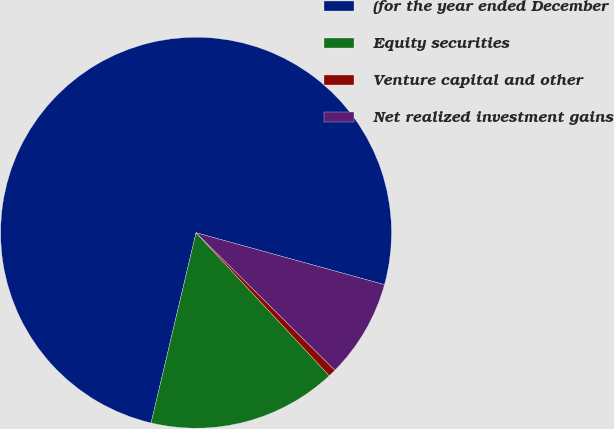Convert chart. <chart><loc_0><loc_0><loc_500><loc_500><pie_chart><fcel>(for the year ended December<fcel>Equity securities<fcel>Venture capital and other<fcel>Net realized investment gains<nl><fcel>75.59%<fcel>15.63%<fcel>0.64%<fcel>8.14%<nl></chart> 